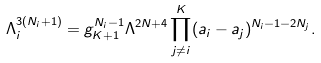<formula> <loc_0><loc_0><loc_500><loc_500>\Lambda _ { i } ^ { 3 ( N _ { i } + 1 ) } = g _ { K + 1 } ^ { N _ { i } - 1 } \Lambda ^ { 2 N + 4 } \prod _ { j \neq i } ^ { K } ( a _ { i } - a _ { j } ) ^ { N _ { i } - 1 - 2 N _ { j } } .</formula> 